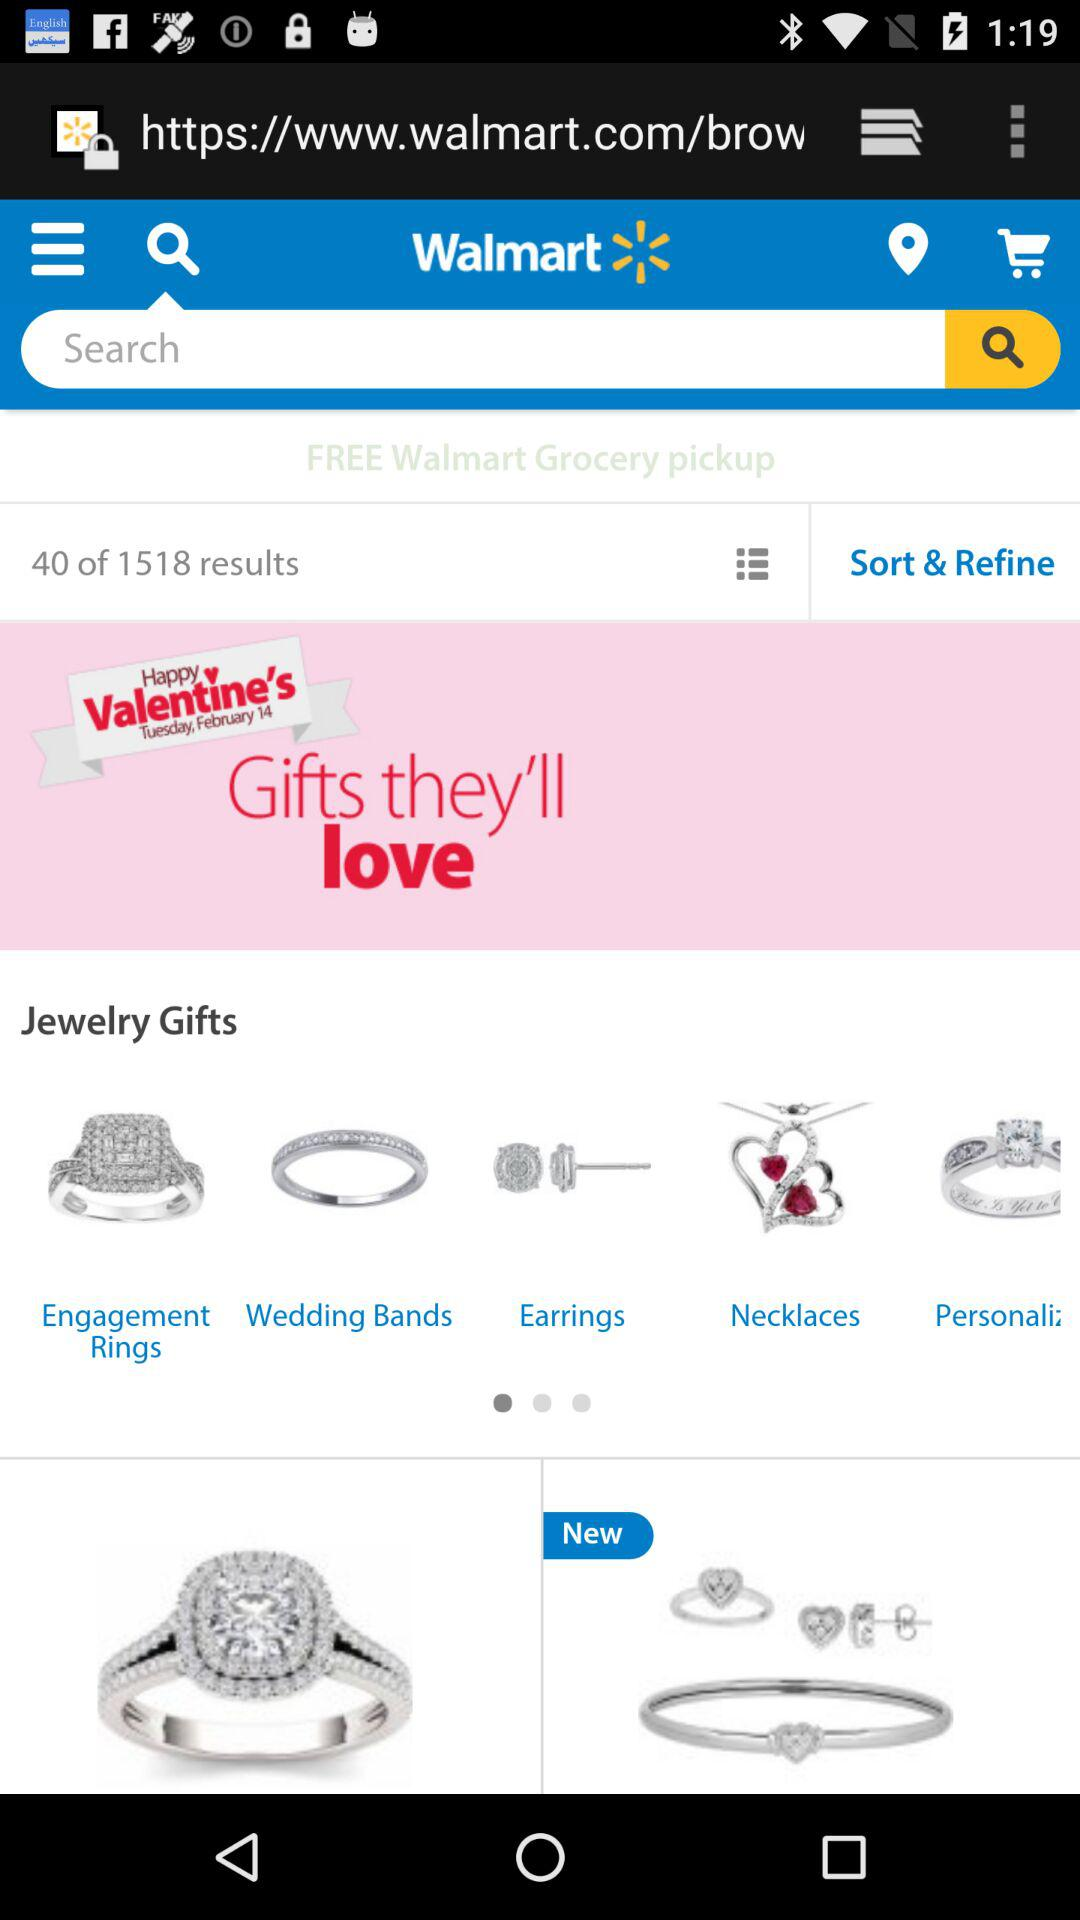How many results are sort and refine?
When the provided information is insufficient, respond with <no answer>. <no answer> 